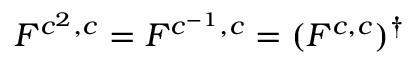Convert formula to latex. <formula><loc_0><loc_0><loc_500><loc_500>F ^ { c ^ { 2 } , c } = F ^ { c ^ { - 1 } , c } = ( F ^ { c , c } ) ^ { \dagger }</formula> 